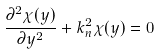<formula> <loc_0><loc_0><loc_500><loc_500>\frac { \partial ^ { 2 } \chi ( y ) } { \partial y ^ { 2 } } + k _ { n } ^ { 2 } \chi ( y ) = 0</formula> 